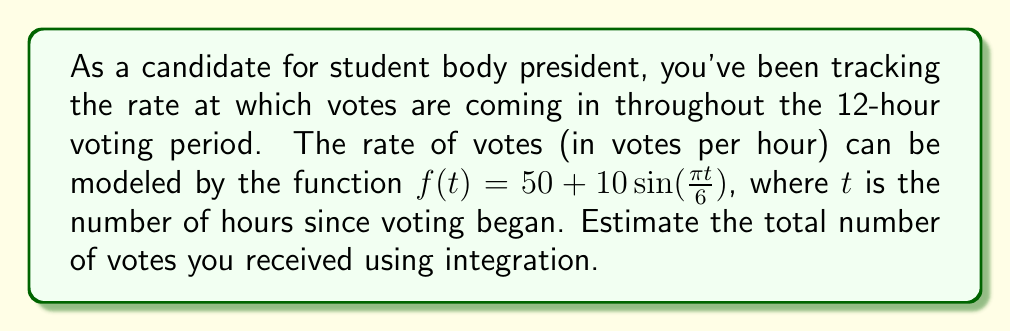Can you solve this math problem? To estimate the total number of votes, we need to integrate the rate function over the entire voting period:

1) Set up the definite integral:
   $$\int_{0}^{12} f(t) dt = \int_{0}^{12} (50 + 10\sin(\frac{\pi t}{6})) dt$$

2) Split the integral:
   $$\int_{0}^{12} 50 dt + \int_{0}^{12} 10\sin(\frac{\pi t}{6}) dt$$

3) Evaluate the first part:
   $$50t \bigg|_{0}^{12} = 50(12) - 50(0) = 600$$

4) For the second part, use u-substitution:
   Let $u = \frac{\pi t}{6}$, then $du = \frac{\pi}{6} dt$ and $dt = \frac{6}{\pi} du$
   
   New limits: when $t=0$, $u=0$; when $t=12$, $u=2\pi$

   $$\frac{60}{\pi} \int_{0}^{2\pi} \sin(u) du$$

5) Evaluate:
   $$\frac{60}{\pi} [-\cos(u)]_{0}^{2\pi} = \frac{60}{\pi} [-\cos(2\pi) + \cos(0)] = 0$$

6) Sum the results from steps 3 and 5:
   Total votes = 600 + 0 = 600
Answer: 600 votes 